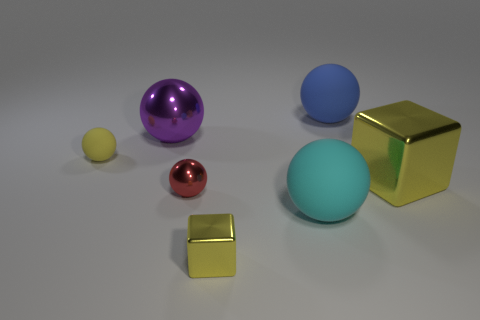Do the large metallic cube and the tiny metallic block have the same color?
Provide a short and direct response. Yes. What number of other blue spheres have the same material as the blue ball?
Provide a short and direct response. 0. The tiny ball that is the same material as the cyan object is what color?
Provide a short and direct response. Yellow. There is a yellow rubber object; does it have the same size as the shiny thing that is right of the large cyan matte sphere?
Ensure brevity in your answer.  No. What is the material of the ball that is right of the large matte object in front of the small rubber sphere behind the small shiny ball?
Your answer should be compact. Rubber. What number of things are either shiny cubes or red things?
Provide a short and direct response. 3. Does the tiny thing that is behind the large yellow metal block have the same color as the metal block that is behind the small metallic ball?
Offer a terse response. Yes. What is the shape of the yellow thing that is the same size as the purple metallic thing?
Provide a succinct answer. Cube. How many objects are small yellow objects that are to the left of the red sphere or blue things behind the big cyan matte ball?
Your answer should be very brief. 2. Are there fewer purple things than yellow blocks?
Give a very brief answer. Yes. 